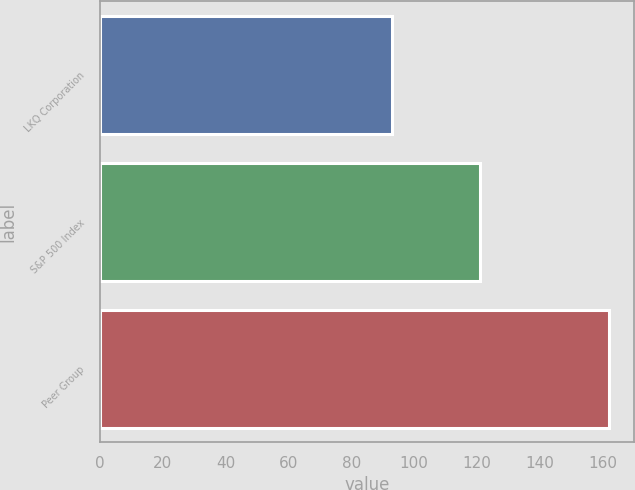Convert chart to OTSL. <chart><loc_0><loc_0><loc_500><loc_500><bar_chart><fcel>LKQ Corporation<fcel>S&P 500 Index<fcel>Peer Group<nl><fcel>93<fcel>121<fcel>162<nl></chart> 